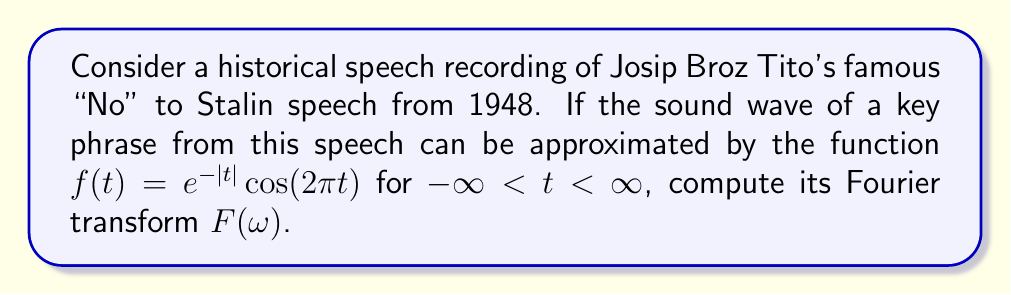Show me your answer to this math problem. Let's approach this step-by-step:

1) The Fourier transform of a function $f(t)$ is given by:

   $$F(\omega) = \int_{-\infty}^{\infty} f(t)e^{-i\omega t}dt$$

2) In our case, $f(t) = e^{-|t|}cos(2\pi t)$. We can rewrite this using Euler's formula:

   $$cos(2\pi t) = \frac{1}{2}(e^{2\pi it} + e^{-2\pi it})$$

3) So, our function becomes:

   $$f(t) = \frac{1}{2}e^{-|t|}(e^{2\pi it} + e^{-2\pi it})$$

4) Now, we need to compute:

   $$F(\omega) = \frac{1}{2}\int_{-\infty}^{\infty} e^{-|t|}(e^{2\pi it} + e^{-2\pi it})e^{-i\omega t}dt$$

5) This can be split into two integrals:

   $$F(\omega) = \frac{1}{2}\int_{-\infty}^{\infty} e^{-|t|}e^{(2\pi-\omega)it}dt + \frac{1}{2}\int_{-\infty}^{\infty} e^{-|t|}e^{-(2\pi+\omega)it}dt$$

6) These integrals can be solved using the property of Fourier transform of an exponential function:

   $$\int_{-\infty}^{\infty} e^{-|t|}e^{i\alpha t}dt = \frac{2}{1+\alpha^2}$$

7) Applying this to our integrals:

   $$F(\omega) = \frac{1}{2}\cdot\frac{2}{1+(2\pi-\omega)^2} + \frac{1}{2}\cdot\frac{2}{1+(2\pi+\omega)^2}$$

8) Simplifying:

   $$F(\omega) = \frac{1}{1+(2\pi-\omega)^2} + \frac{1}{1+(2\pi+\omega)^2}$$

This is the Fourier transform of the given sound wave function.
Answer: $$F(\omega) = \frac{1}{1+(2\pi-\omega)^2} + \frac{1}{1+(2\pi+\omega)^2}$$ 